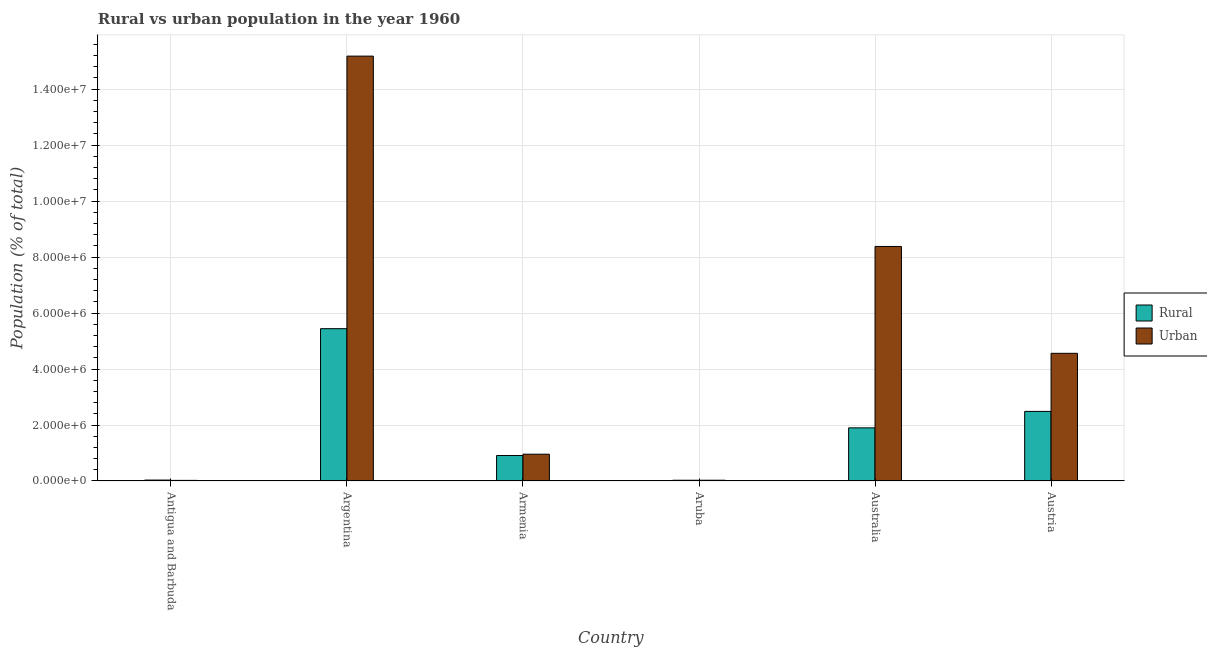How many different coloured bars are there?
Offer a terse response. 2. How many bars are there on the 4th tick from the left?
Offer a very short reply. 2. How many bars are there on the 3rd tick from the right?
Keep it short and to the point. 2. What is the urban population density in Australia?
Give a very brief answer. 8.38e+06. Across all countries, what is the maximum urban population density?
Offer a terse response. 1.52e+07. Across all countries, what is the minimum rural population density?
Provide a succinct answer. 2.67e+04. In which country was the urban population density maximum?
Give a very brief answer. Argentina. In which country was the rural population density minimum?
Your answer should be compact. Aruba. What is the total rural population density in the graph?
Offer a very short reply. 1.08e+07. What is the difference between the rural population density in Antigua and Barbuda and that in Argentina?
Give a very brief answer. -5.41e+06. What is the difference between the rural population density in Australia and the urban population density in Argentina?
Your answer should be compact. -1.33e+07. What is the average urban population density per country?
Keep it short and to the point. 4.85e+06. What is the difference between the rural population density and urban population density in Argentina?
Your answer should be compact. -9.74e+06. In how many countries, is the rural population density greater than 6800000 %?
Your answer should be compact. 0. What is the ratio of the urban population density in Armenia to that in Aruba?
Provide a short and direct response. 34.79. What is the difference between the highest and the second highest rural population density?
Your response must be concise. 2.95e+06. What is the difference between the highest and the lowest rural population density?
Keep it short and to the point. 5.41e+06. In how many countries, is the rural population density greater than the average rural population density taken over all countries?
Keep it short and to the point. 3. Is the sum of the rural population density in Argentina and Austria greater than the maximum urban population density across all countries?
Offer a very short reply. No. What does the 2nd bar from the left in Argentina represents?
Offer a terse response. Urban. What does the 2nd bar from the right in Aruba represents?
Ensure brevity in your answer.  Rural. How many countries are there in the graph?
Give a very brief answer. 6. What is the difference between two consecutive major ticks on the Y-axis?
Offer a terse response. 2.00e+06. Does the graph contain any zero values?
Offer a terse response. No. Where does the legend appear in the graph?
Make the answer very short. Center right. How many legend labels are there?
Your answer should be very brief. 2. What is the title of the graph?
Offer a very short reply. Rural vs urban population in the year 1960. Does "Constant 2005 US$" appear as one of the legend labels in the graph?
Your answer should be compact. No. What is the label or title of the X-axis?
Offer a terse response. Country. What is the label or title of the Y-axis?
Your response must be concise. Population (% of total). What is the Population (% of total) in Rural in Antigua and Barbuda?
Your response must be concise. 3.30e+04. What is the Population (% of total) of Urban in Antigua and Barbuda?
Keep it short and to the point. 2.17e+04. What is the Population (% of total) in Rural in Argentina?
Your response must be concise. 5.44e+06. What is the Population (% of total) of Urban in Argentina?
Ensure brevity in your answer.  1.52e+07. What is the Population (% of total) in Rural in Armenia?
Make the answer very short. 9.10e+05. What is the Population (% of total) of Urban in Armenia?
Offer a very short reply. 9.58e+05. What is the Population (% of total) in Rural in Aruba?
Make the answer very short. 2.67e+04. What is the Population (% of total) of Urban in Aruba?
Ensure brevity in your answer.  2.75e+04. What is the Population (% of total) in Rural in Australia?
Offer a terse response. 1.90e+06. What is the Population (% of total) of Urban in Australia?
Provide a short and direct response. 8.38e+06. What is the Population (% of total) in Rural in Austria?
Your response must be concise. 2.49e+06. What is the Population (% of total) of Urban in Austria?
Ensure brevity in your answer.  4.56e+06. Across all countries, what is the maximum Population (% of total) in Rural?
Ensure brevity in your answer.  5.44e+06. Across all countries, what is the maximum Population (% of total) of Urban?
Your answer should be compact. 1.52e+07. Across all countries, what is the minimum Population (% of total) in Rural?
Make the answer very short. 2.67e+04. Across all countries, what is the minimum Population (% of total) in Urban?
Keep it short and to the point. 2.17e+04. What is the total Population (% of total) in Rural in the graph?
Provide a short and direct response. 1.08e+07. What is the total Population (% of total) in Urban in the graph?
Your answer should be compact. 2.91e+07. What is the difference between the Population (% of total) of Rural in Antigua and Barbuda and that in Argentina?
Provide a succinct answer. -5.41e+06. What is the difference between the Population (% of total) in Urban in Antigua and Barbuda and that in Argentina?
Your answer should be very brief. -1.52e+07. What is the difference between the Population (% of total) in Rural in Antigua and Barbuda and that in Armenia?
Ensure brevity in your answer.  -8.77e+05. What is the difference between the Population (% of total) of Urban in Antigua and Barbuda and that in Armenia?
Make the answer very short. -9.36e+05. What is the difference between the Population (% of total) of Rural in Antigua and Barbuda and that in Aruba?
Make the answer very short. 6314. What is the difference between the Population (% of total) in Urban in Antigua and Barbuda and that in Aruba?
Make the answer very short. -5841. What is the difference between the Population (% of total) of Rural in Antigua and Barbuda and that in Australia?
Your answer should be compact. -1.87e+06. What is the difference between the Population (% of total) of Urban in Antigua and Barbuda and that in Australia?
Make the answer very short. -8.36e+06. What is the difference between the Population (% of total) of Rural in Antigua and Barbuda and that in Austria?
Your answer should be compact. -2.45e+06. What is the difference between the Population (% of total) of Urban in Antigua and Barbuda and that in Austria?
Your answer should be very brief. -4.54e+06. What is the difference between the Population (% of total) of Rural in Argentina and that in Armenia?
Provide a short and direct response. 4.53e+06. What is the difference between the Population (% of total) in Urban in Argentina and that in Armenia?
Your answer should be very brief. 1.42e+07. What is the difference between the Population (% of total) of Rural in Argentina and that in Aruba?
Your answer should be compact. 5.41e+06. What is the difference between the Population (% of total) in Urban in Argentina and that in Aruba?
Give a very brief answer. 1.52e+07. What is the difference between the Population (% of total) of Rural in Argentina and that in Australia?
Your answer should be compact. 3.54e+06. What is the difference between the Population (% of total) in Urban in Argentina and that in Australia?
Your response must be concise. 6.80e+06. What is the difference between the Population (% of total) in Rural in Argentina and that in Austria?
Give a very brief answer. 2.95e+06. What is the difference between the Population (% of total) of Urban in Argentina and that in Austria?
Your response must be concise. 1.06e+07. What is the difference between the Population (% of total) in Rural in Armenia and that in Aruba?
Make the answer very short. 8.83e+05. What is the difference between the Population (% of total) in Urban in Armenia and that in Aruba?
Offer a terse response. 9.30e+05. What is the difference between the Population (% of total) of Rural in Armenia and that in Australia?
Keep it short and to the point. -9.88e+05. What is the difference between the Population (% of total) in Urban in Armenia and that in Australia?
Your answer should be compact. -7.42e+06. What is the difference between the Population (% of total) in Rural in Armenia and that in Austria?
Your response must be concise. -1.58e+06. What is the difference between the Population (% of total) of Urban in Armenia and that in Austria?
Ensure brevity in your answer.  -3.60e+06. What is the difference between the Population (% of total) in Rural in Aruba and that in Australia?
Offer a terse response. -1.87e+06. What is the difference between the Population (% of total) in Urban in Aruba and that in Australia?
Your answer should be very brief. -8.35e+06. What is the difference between the Population (% of total) of Rural in Aruba and that in Austria?
Offer a terse response. -2.46e+06. What is the difference between the Population (% of total) of Urban in Aruba and that in Austria?
Offer a very short reply. -4.53e+06. What is the difference between the Population (% of total) of Rural in Australia and that in Austria?
Your answer should be compact. -5.88e+05. What is the difference between the Population (% of total) in Urban in Australia and that in Austria?
Offer a terse response. 3.82e+06. What is the difference between the Population (% of total) in Rural in Antigua and Barbuda and the Population (% of total) in Urban in Argentina?
Provide a short and direct response. -1.51e+07. What is the difference between the Population (% of total) in Rural in Antigua and Barbuda and the Population (% of total) in Urban in Armenia?
Offer a terse response. -9.25e+05. What is the difference between the Population (% of total) of Rural in Antigua and Barbuda and the Population (% of total) of Urban in Aruba?
Keep it short and to the point. 5472. What is the difference between the Population (% of total) of Rural in Antigua and Barbuda and the Population (% of total) of Urban in Australia?
Your response must be concise. -8.35e+06. What is the difference between the Population (% of total) in Rural in Antigua and Barbuda and the Population (% of total) in Urban in Austria?
Give a very brief answer. -4.53e+06. What is the difference between the Population (% of total) of Rural in Argentina and the Population (% of total) of Urban in Armenia?
Offer a very short reply. 4.48e+06. What is the difference between the Population (% of total) of Rural in Argentina and the Population (% of total) of Urban in Aruba?
Offer a very short reply. 5.41e+06. What is the difference between the Population (% of total) in Rural in Argentina and the Population (% of total) in Urban in Australia?
Offer a terse response. -2.94e+06. What is the difference between the Population (% of total) in Rural in Argentina and the Population (% of total) in Urban in Austria?
Make the answer very short. 8.80e+05. What is the difference between the Population (% of total) in Rural in Armenia and the Population (% of total) in Urban in Aruba?
Offer a terse response. 8.82e+05. What is the difference between the Population (% of total) of Rural in Armenia and the Population (% of total) of Urban in Australia?
Your response must be concise. -7.47e+06. What is the difference between the Population (% of total) of Rural in Armenia and the Population (% of total) of Urban in Austria?
Give a very brief answer. -3.65e+06. What is the difference between the Population (% of total) in Rural in Aruba and the Population (% of total) in Urban in Australia?
Ensure brevity in your answer.  -8.35e+06. What is the difference between the Population (% of total) in Rural in Aruba and the Population (% of total) in Urban in Austria?
Offer a very short reply. -4.53e+06. What is the difference between the Population (% of total) in Rural in Australia and the Population (% of total) in Urban in Austria?
Ensure brevity in your answer.  -2.66e+06. What is the average Population (% of total) in Rural per country?
Offer a very short reply. 1.80e+06. What is the average Population (% of total) of Urban per country?
Provide a succinct answer. 4.85e+06. What is the difference between the Population (% of total) of Rural and Population (% of total) of Urban in Antigua and Barbuda?
Your response must be concise. 1.13e+04. What is the difference between the Population (% of total) in Rural and Population (% of total) in Urban in Argentina?
Keep it short and to the point. -9.74e+06. What is the difference between the Population (% of total) in Rural and Population (% of total) in Urban in Armenia?
Provide a short and direct response. -4.76e+04. What is the difference between the Population (% of total) in Rural and Population (% of total) in Urban in Aruba?
Your answer should be compact. -842. What is the difference between the Population (% of total) in Rural and Population (% of total) in Urban in Australia?
Ensure brevity in your answer.  -6.48e+06. What is the difference between the Population (% of total) in Rural and Population (% of total) in Urban in Austria?
Offer a terse response. -2.07e+06. What is the ratio of the Population (% of total) in Rural in Antigua and Barbuda to that in Argentina?
Your answer should be compact. 0.01. What is the ratio of the Population (% of total) in Urban in Antigua and Barbuda to that in Argentina?
Offer a terse response. 0. What is the ratio of the Population (% of total) in Rural in Antigua and Barbuda to that in Armenia?
Provide a succinct answer. 0.04. What is the ratio of the Population (% of total) of Urban in Antigua and Barbuda to that in Armenia?
Make the answer very short. 0.02. What is the ratio of the Population (% of total) in Rural in Antigua and Barbuda to that in Aruba?
Ensure brevity in your answer.  1.24. What is the ratio of the Population (% of total) of Urban in Antigua and Barbuda to that in Aruba?
Offer a terse response. 0.79. What is the ratio of the Population (% of total) of Rural in Antigua and Barbuda to that in Australia?
Provide a succinct answer. 0.02. What is the ratio of the Population (% of total) of Urban in Antigua and Barbuda to that in Australia?
Keep it short and to the point. 0. What is the ratio of the Population (% of total) in Rural in Antigua and Barbuda to that in Austria?
Ensure brevity in your answer.  0.01. What is the ratio of the Population (% of total) of Urban in Antigua and Barbuda to that in Austria?
Your answer should be compact. 0. What is the ratio of the Population (% of total) of Rural in Argentina to that in Armenia?
Your answer should be compact. 5.98. What is the ratio of the Population (% of total) of Urban in Argentina to that in Armenia?
Ensure brevity in your answer.  15.85. What is the ratio of the Population (% of total) of Rural in Argentina to that in Aruba?
Make the answer very short. 203.92. What is the ratio of the Population (% of total) in Urban in Argentina to that in Aruba?
Give a very brief answer. 551.42. What is the ratio of the Population (% of total) of Rural in Argentina to that in Australia?
Provide a short and direct response. 2.87. What is the ratio of the Population (% of total) of Urban in Argentina to that in Australia?
Offer a very short reply. 1.81. What is the ratio of the Population (% of total) in Rural in Argentina to that in Austria?
Your answer should be very brief. 2.19. What is the ratio of the Population (% of total) of Urban in Argentina to that in Austria?
Keep it short and to the point. 3.33. What is the ratio of the Population (% of total) in Rural in Armenia to that in Aruba?
Keep it short and to the point. 34.1. What is the ratio of the Population (% of total) in Urban in Armenia to that in Aruba?
Ensure brevity in your answer.  34.79. What is the ratio of the Population (% of total) in Rural in Armenia to that in Australia?
Your response must be concise. 0.48. What is the ratio of the Population (% of total) of Urban in Armenia to that in Australia?
Keep it short and to the point. 0.11. What is the ratio of the Population (% of total) of Rural in Armenia to that in Austria?
Offer a very short reply. 0.37. What is the ratio of the Population (% of total) in Urban in Armenia to that in Austria?
Your response must be concise. 0.21. What is the ratio of the Population (% of total) of Rural in Aruba to that in Australia?
Provide a short and direct response. 0.01. What is the ratio of the Population (% of total) in Urban in Aruba to that in Australia?
Offer a very short reply. 0. What is the ratio of the Population (% of total) of Rural in Aruba to that in Austria?
Provide a succinct answer. 0.01. What is the ratio of the Population (% of total) of Urban in Aruba to that in Austria?
Make the answer very short. 0.01. What is the ratio of the Population (% of total) in Rural in Australia to that in Austria?
Make the answer very short. 0.76. What is the ratio of the Population (% of total) in Urban in Australia to that in Austria?
Offer a very short reply. 1.84. What is the difference between the highest and the second highest Population (% of total) of Rural?
Give a very brief answer. 2.95e+06. What is the difference between the highest and the second highest Population (% of total) of Urban?
Offer a very short reply. 6.80e+06. What is the difference between the highest and the lowest Population (% of total) of Rural?
Keep it short and to the point. 5.41e+06. What is the difference between the highest and the lowest Population (% of total) of Urban?
Your answer should be very brief. 1.52e+07. 